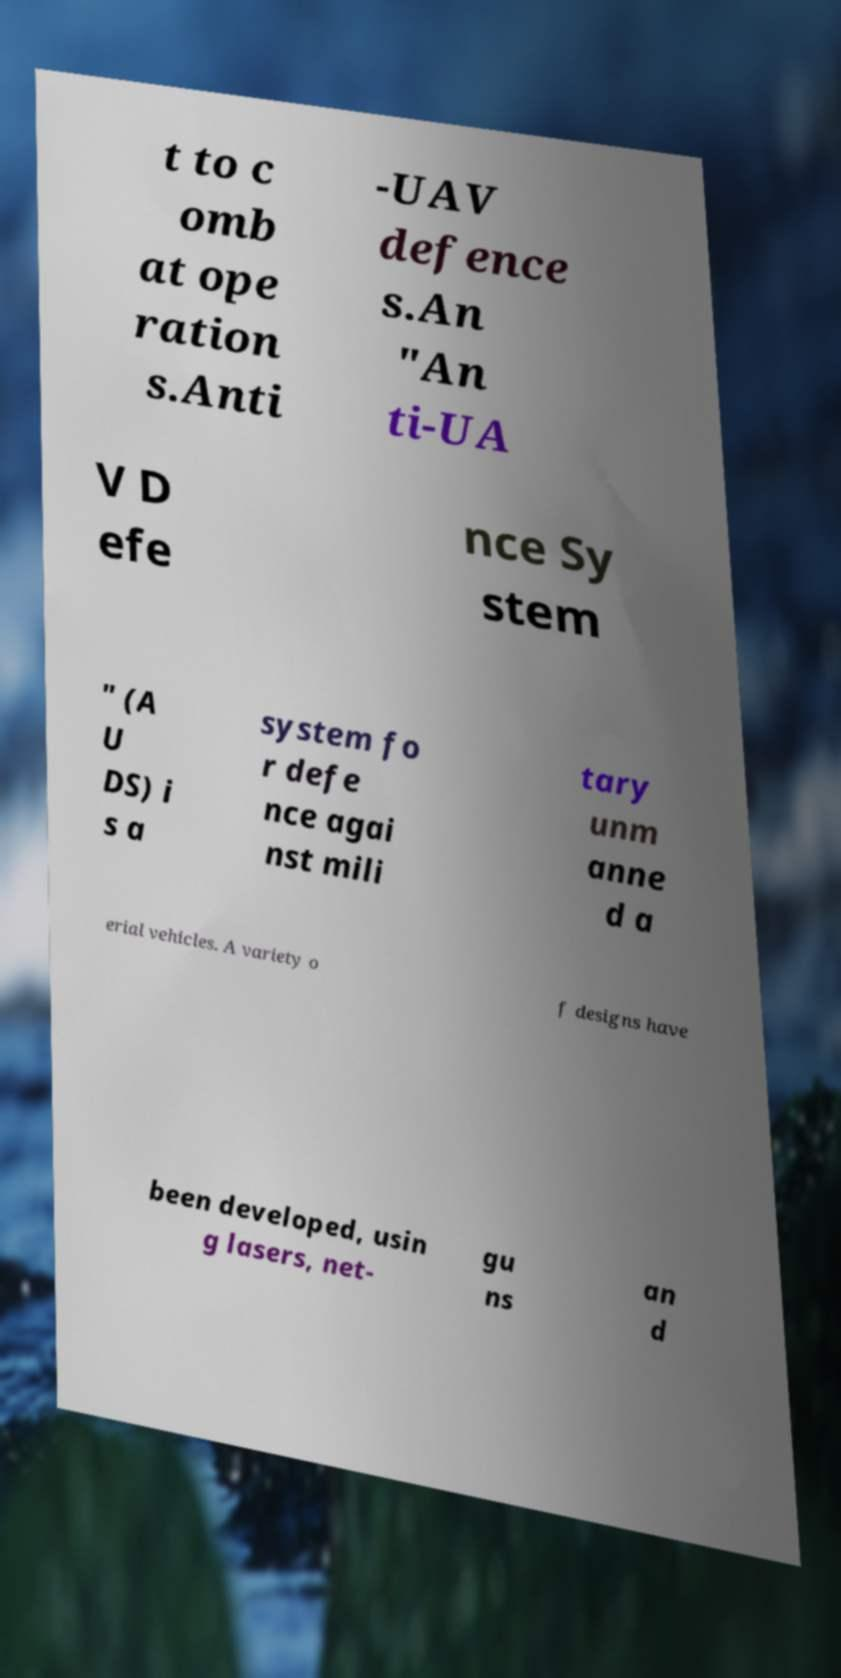There's text embedded in this image that I need extracted. Can you transcribe it verbatim? t to c omb at ope ration s.Anti -UAV defence s.An "An ti-UA V D efe nce Sy stem " (A U DS) i s a system fo r defe nce agai nst mili tary unm anne d a erial vehicles. A variety o f designs have been developed, usin g lasers, net- gu ns an d 